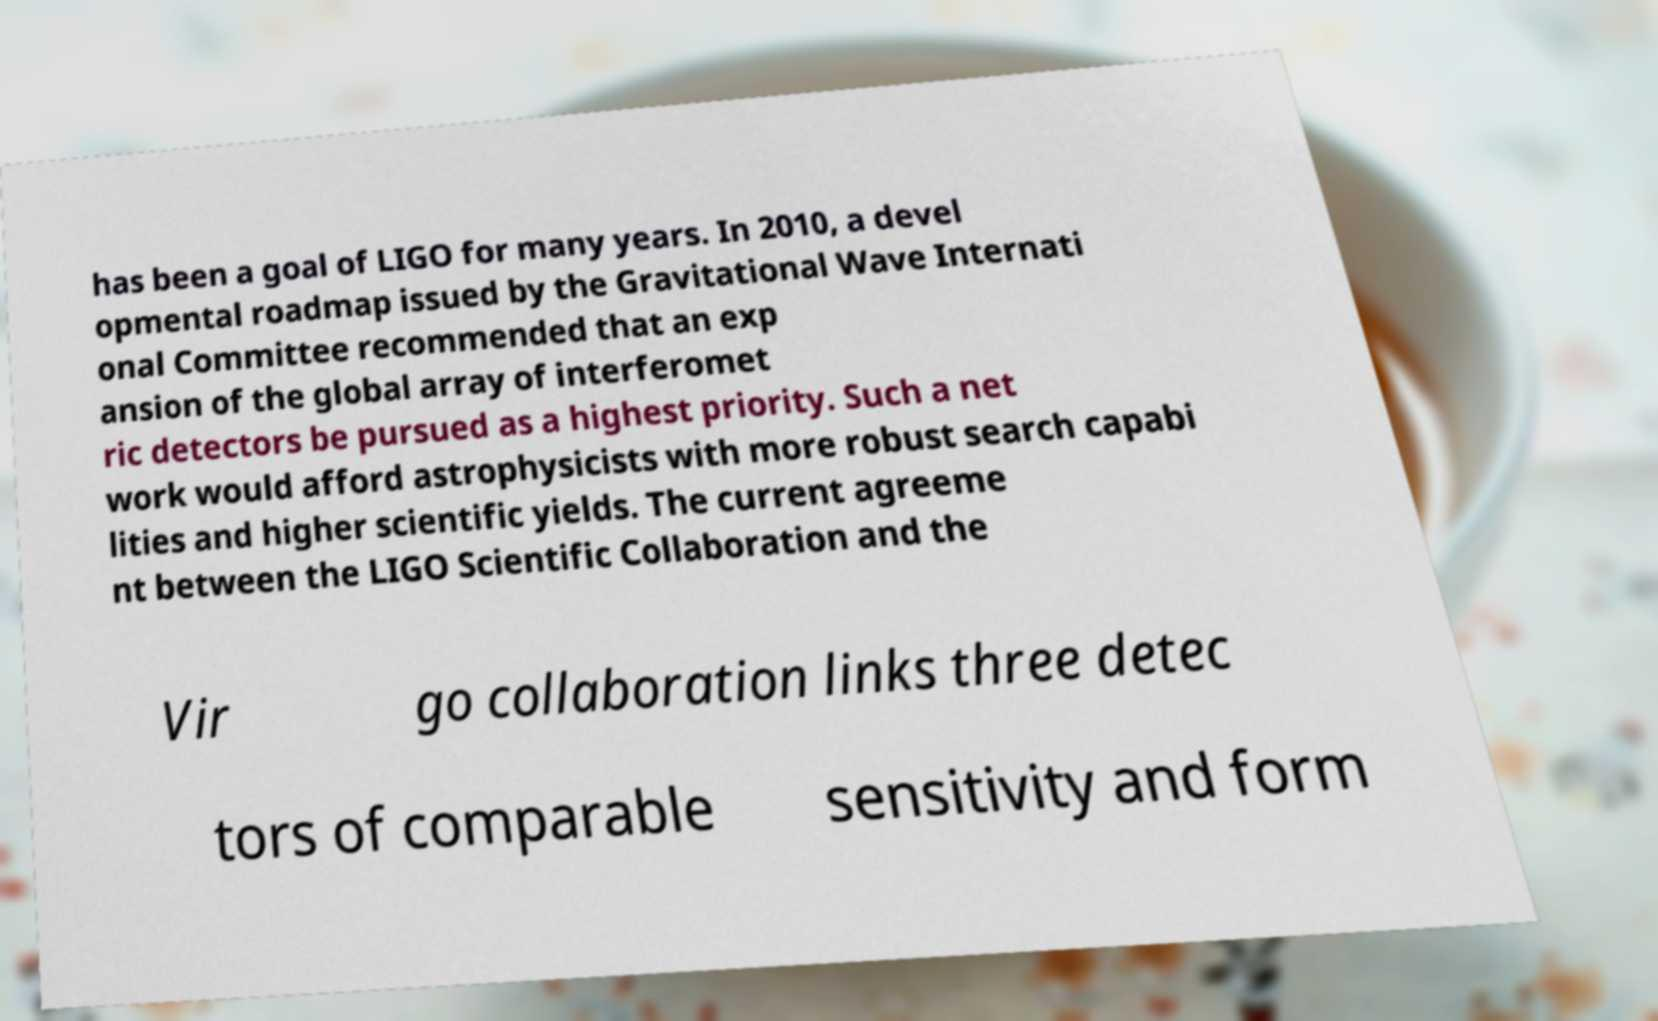What messages or text are displayed in this image? I need them in a readable, typed format. has been a goal of LIGO for many years. In 2010, a devel opmental roadmap issued by the Gravitational Wave Internati onal Committee recommended that an exp ansion of the global array of interferomet ric detectors be pursued as a highest priority. Such a net work would afford astrophysicists with more robust search capabi lities and higher scientific yields. The current agreeme nt between the LIGO Scientific Collaboration and the Vir go collaboration links three detec tors of comparable sensitivity and form 